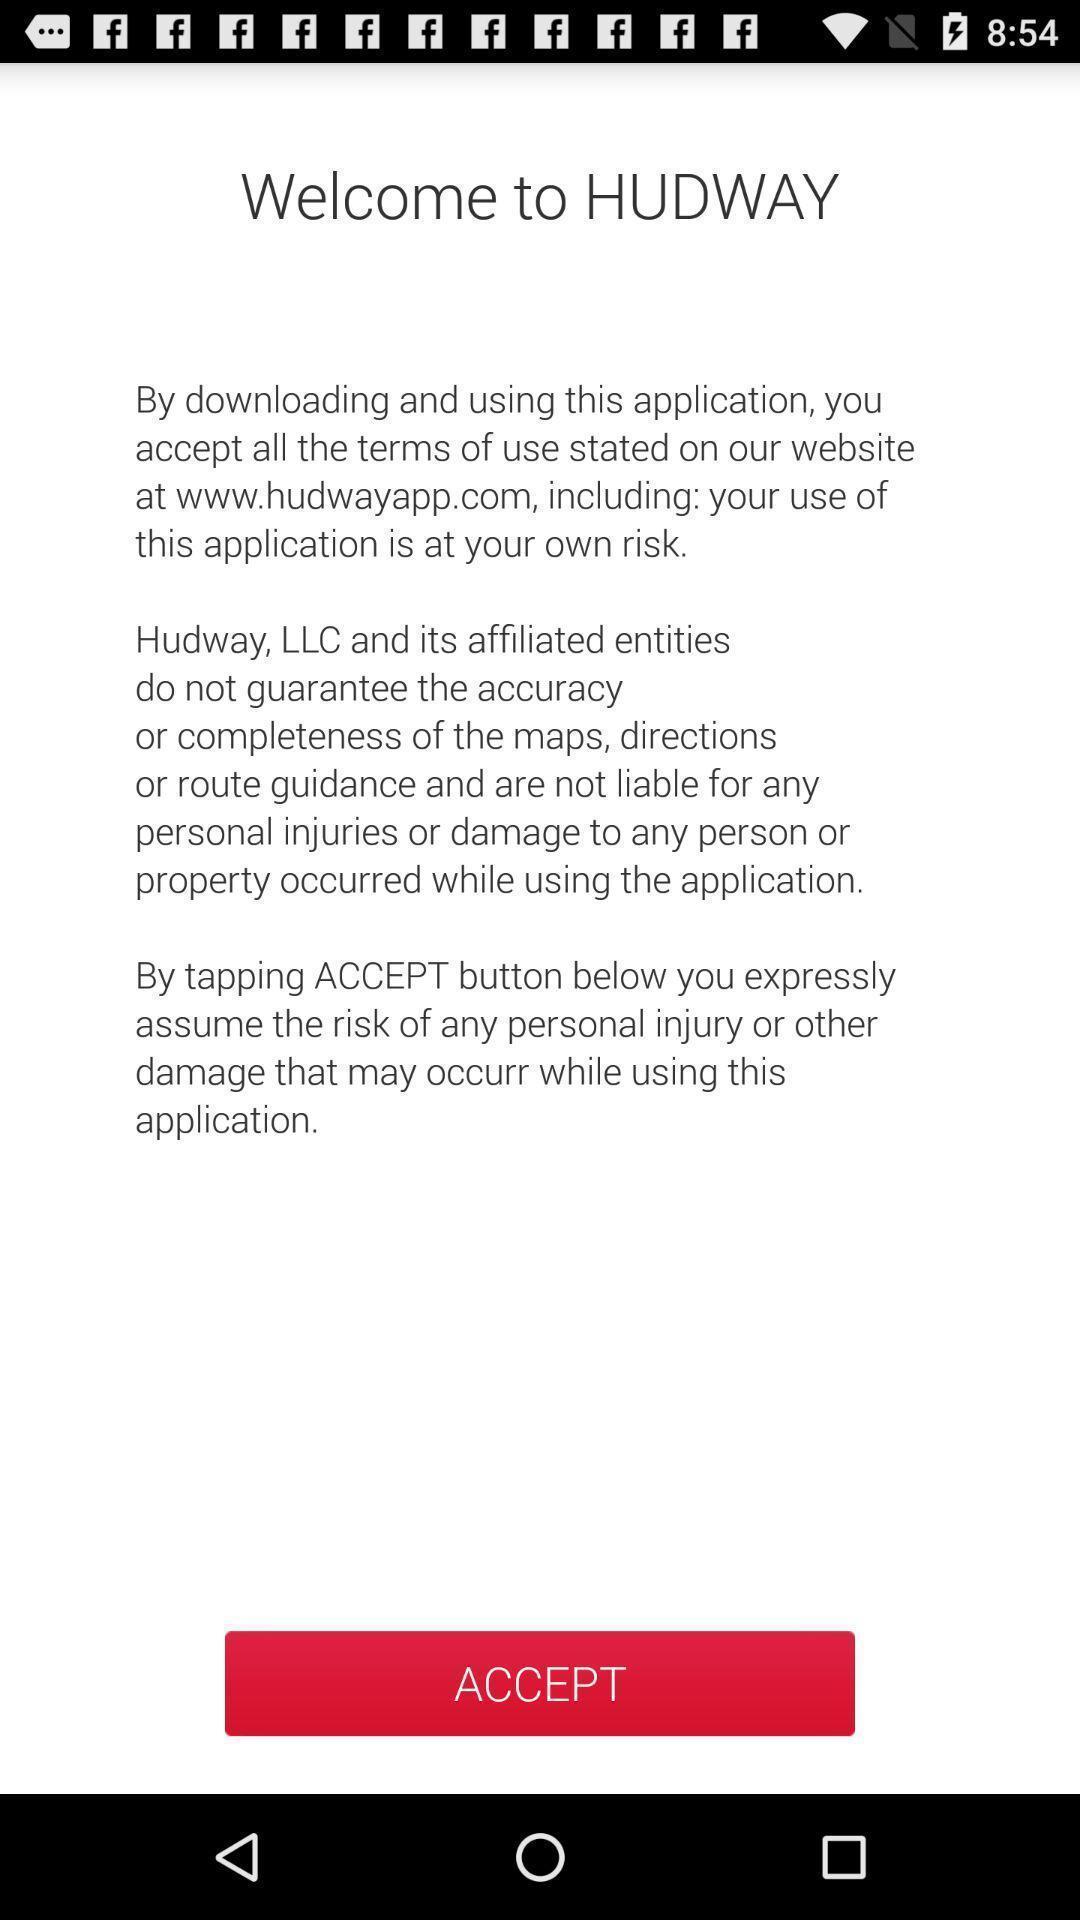Provide a textual representation of this image. Welcome page. 